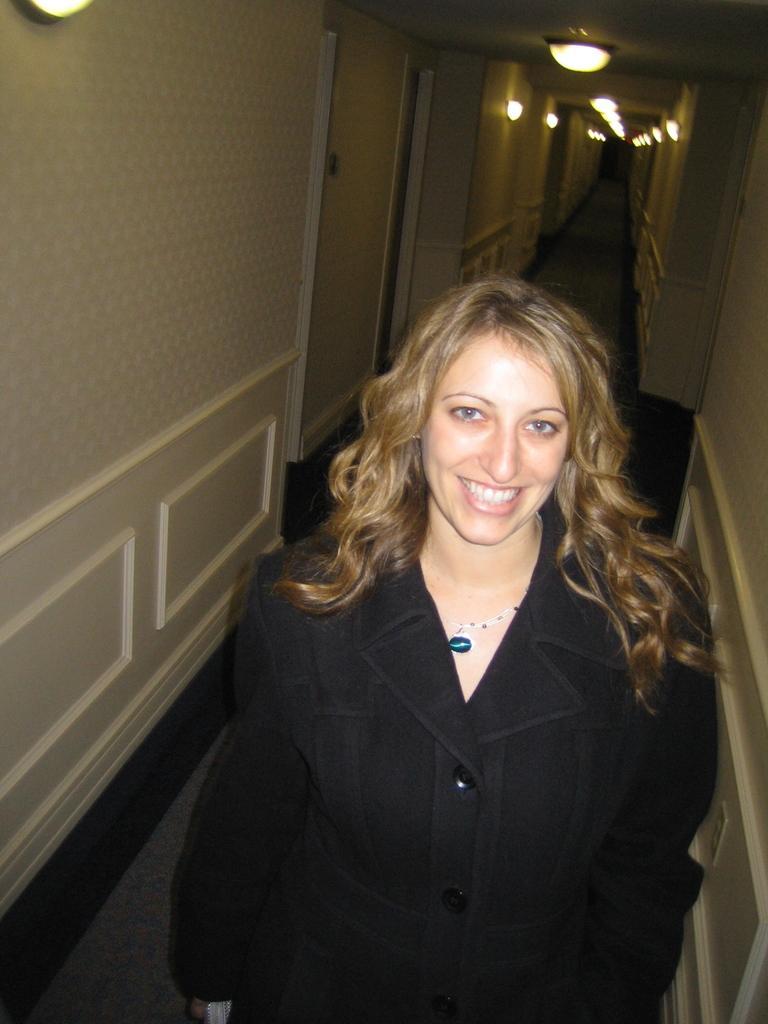Could you give a brief overview of what you see in this image? In this picture I can see there is a woman standing and smiling and in the backdrop there are doors and lights attached to the ceiling. 